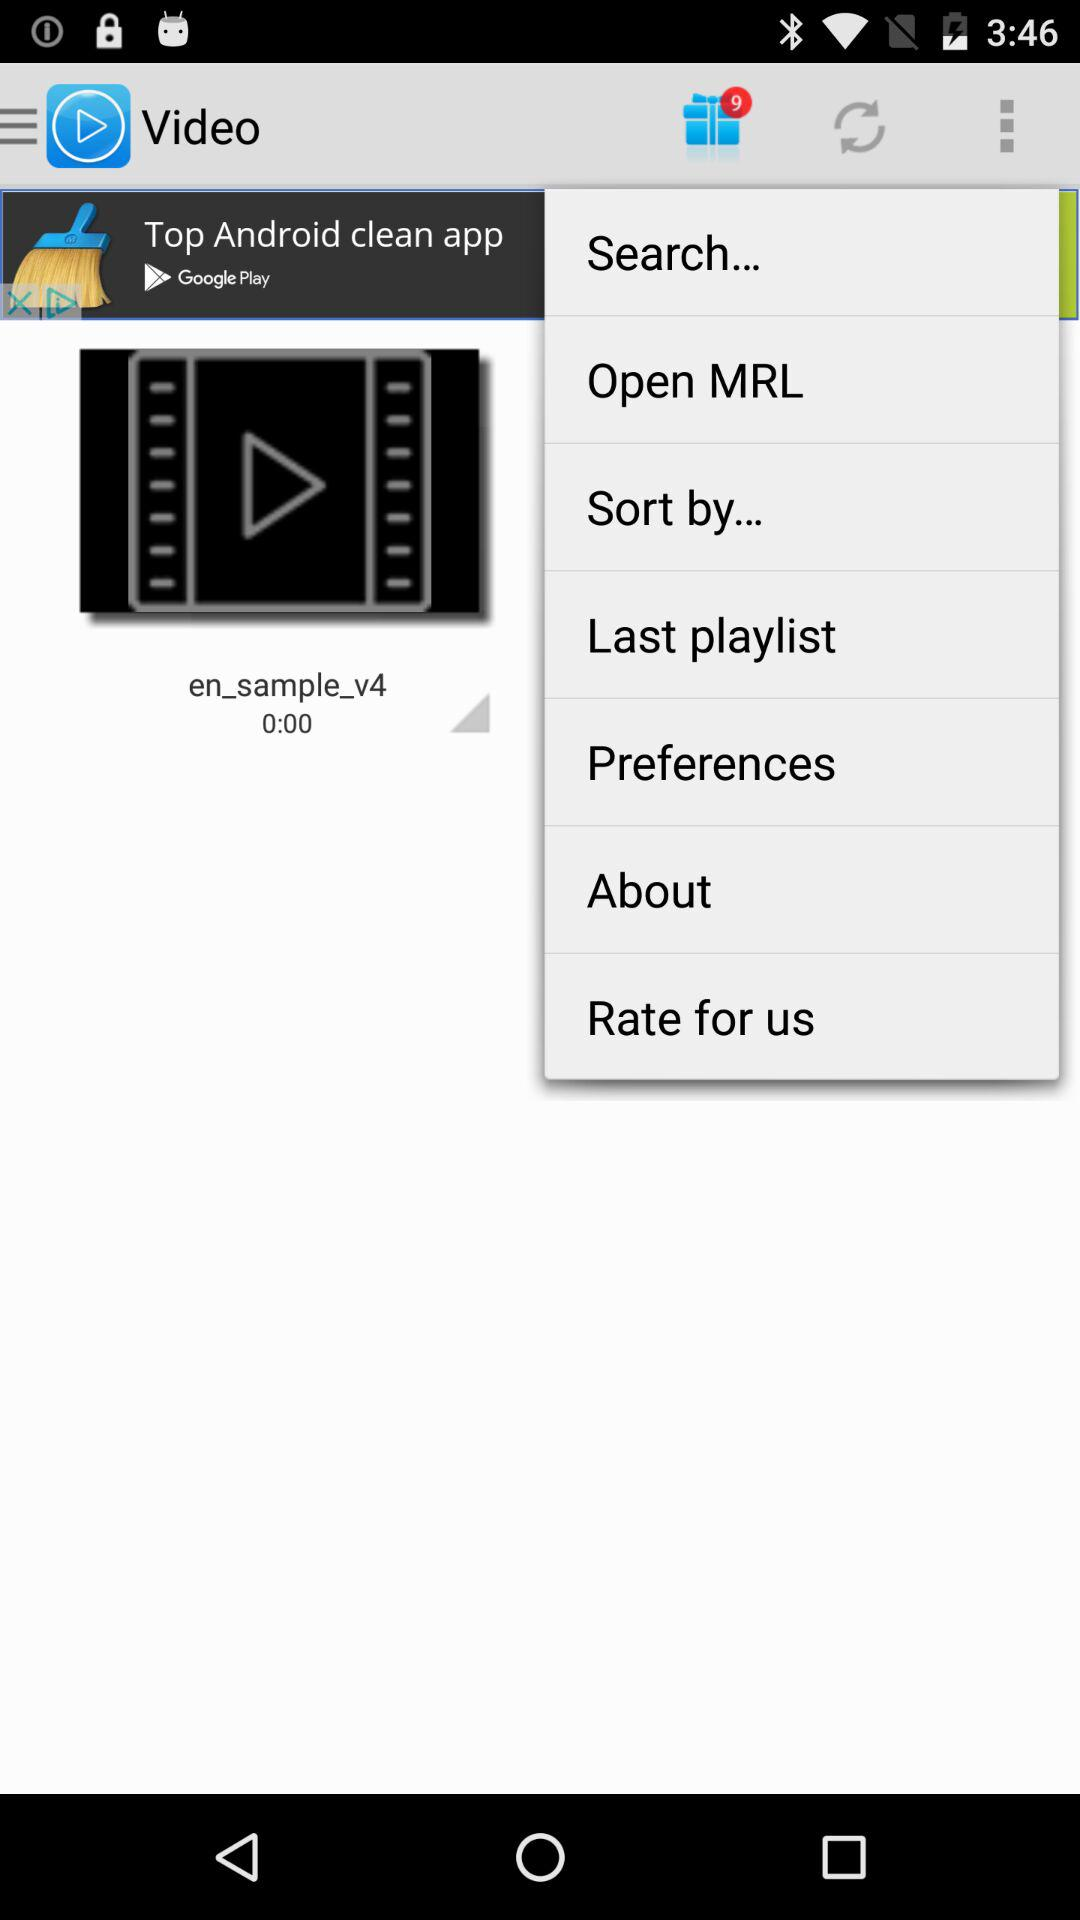How many gifts are pending to be opened? There are 9 gifts pending to be opened. 